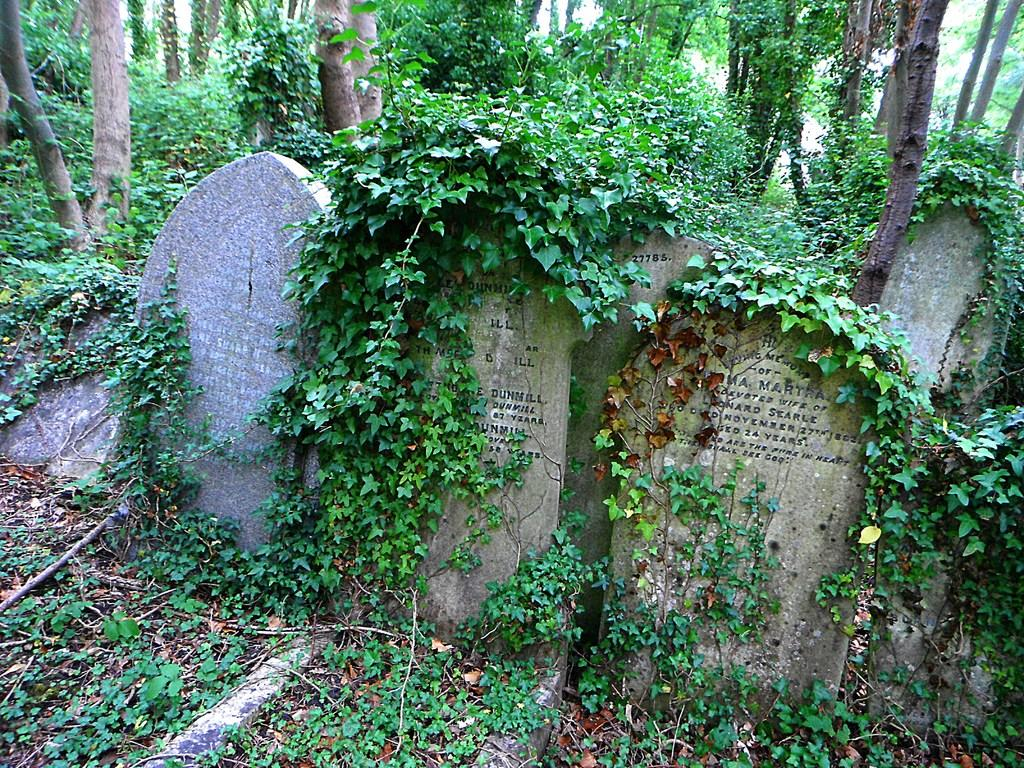What type of location is depicted in the image? The image contains cemeteries. What can be seen in the background of the image? There are plants and trees in the background of the image. What is the color of the plants and trees in the image? The plants and trees are green in color. Where is the toothbrush located in the image? There is no toothbrush present in the image. What type of fruit can be seen hanging from the trees in the image? The provided facts do not mention any fruit, so we cannot determine if cherries or any other fruit is hanging from the trees. 